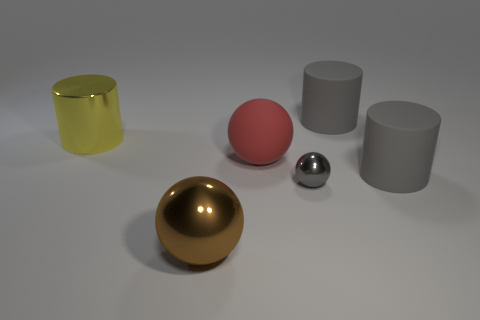Subtract all red spheres. How many spheres are left? 2 Subtract all gray cylinders. How many cylinders are left? 1 Add 3 spheres. How many objects exist? 9 Subtract 1 cylinders. How many cylinders are left? 2 Subtract all gray cylinders. How many yellow spheres are left? 0 Subtract all purple cylinders. Subtract all gray spheres. How many cylinders are left? 3 Add 2 big metal spheres. How many big metal spheres are left? 3 Add 2 brown things. How many brown things exist? 3 Subtract 0 cyan blocks. How many objects are left? 6 Subtract all small gray things. Subtract all small brown metallic cylinders. How many objects are left? 5 